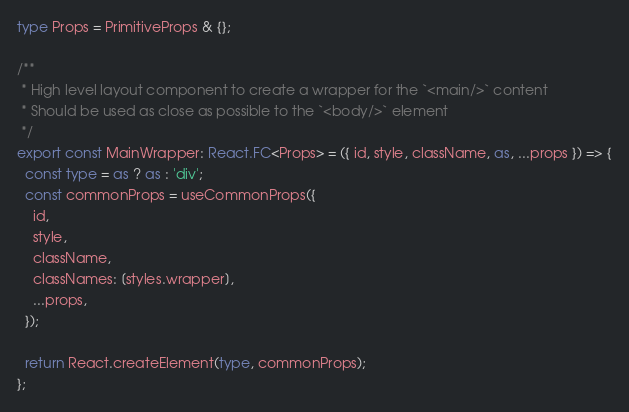Convert code to text. <code><loc_0><loc_0><loc_500><loc_500><_TypeScript_>type Props = PrimitiveProps & {};

/**
 * High level layout component to create a wrapper for the `<main/>` content
 * Should be used as close as possible to the `<body/>` element
 */
export const MainWrapper: React.FC<Props> = ({ id, style, className, as, ...props }) => {
  const type = as ? as : 'div';
  const commonProps = useCommonProps({
    id,
    style,
    className,
    classNames: [styles.wrapper],
    ...props,
  });

  return React.createElement(type, commonProps);
};
</code> 